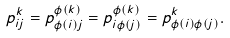Convert formula to latex. <formula><loc_0><loc_0><loc_500><loc_500>p ^ { k } _ { i j } = p ^ { \phi ( k ) } _ { \phi ( i ) j } = p ^ { \phi ( k ) } _ { i \phi ( j ) } = p ^ { k } _ { \phi ( i ) \phi ( j ) } .</formula> 